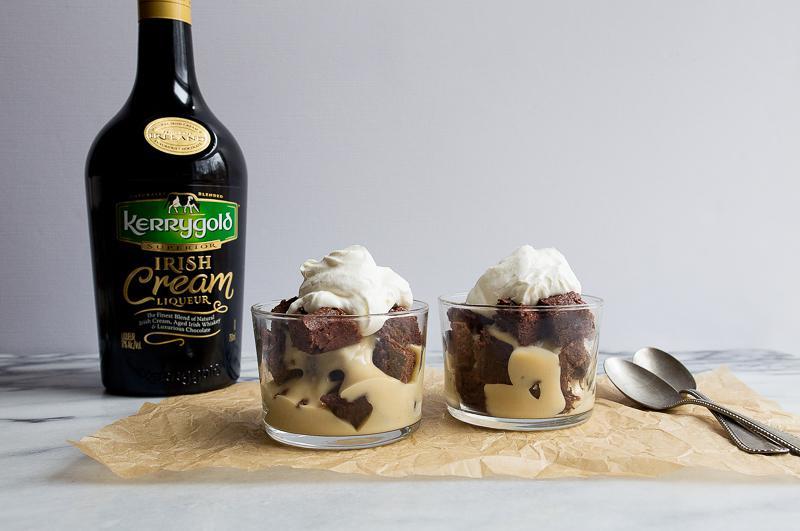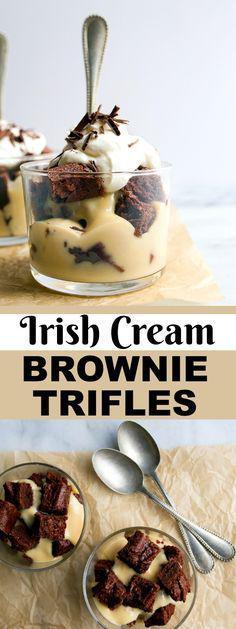The first image is the image on the left, the second image is the image on the right. Given the left and right images, does the statement "There are two individual servings of desserts in the image on the left." hold true? Answer yes or no. Yes. 